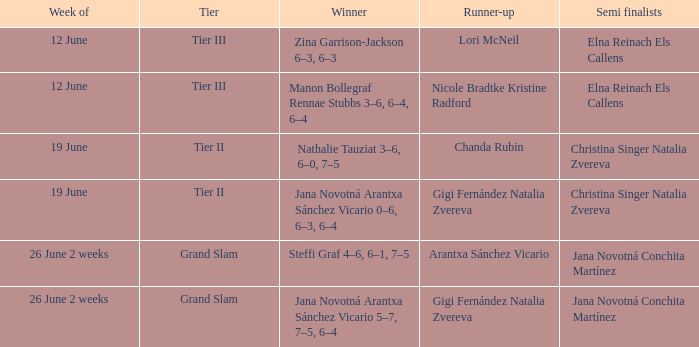Who emerged as the champion during the week of june 26 for a two-week period, with arantxa sánchez vicario being the second-place finisher? Steffi Graf 4–6, 6–1, 7–5. 